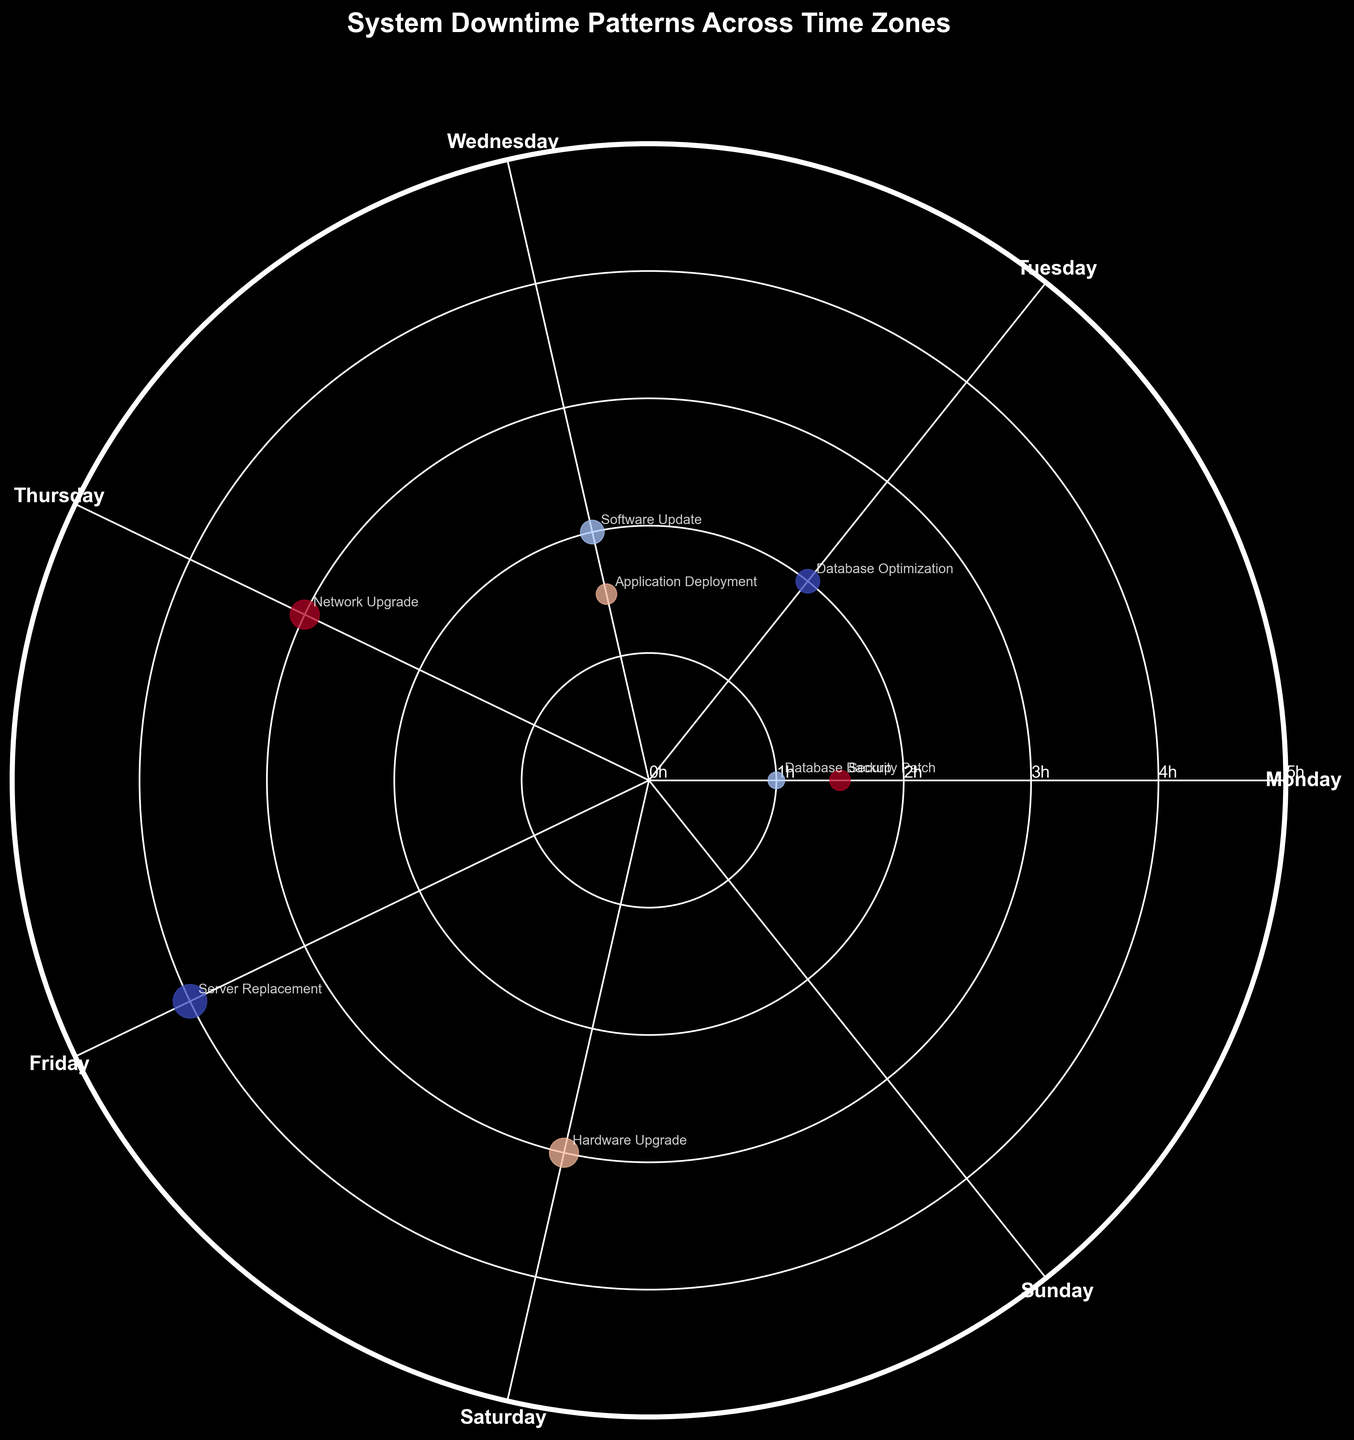What is the maximum system downtime duration displayed in the plot? The maximum downtime can be found by looking at the outermost points along the radial axis. The highest value on the plot is 4 hours.
Answer: 4 hours Which day of the week had the highest total hours of downtime and how many hours was it? To find this, sum up the total downtime hours for each day, then compare the results. The figure shows that Friday had the highest total with 4 hours of downtime.
Answer: Friday, 4 hours Which maintenance activity has the smallest marker size and on what day did it occur? Marker sizes represent hours of downtime. The smallest marker (1 hour), due to its size, is associated with 'Database Backup' on Monday.
Answer: Database Backup, Monday Compare the total downtime hours in PST and EST time zones. Which time zone had more downtime hours and by how many? Sum the downtime hours in EST (1+2=3) and PST (3+1.5=4.5) and then compare. PST had 1.5 more hours of downtime than EST.
Answer: PST, 1.5 hours What patterns are visible in application deployment activities across different time zones? By looking at the positions and labels, application deployment is marked in IST on Wednesday with 1.5 hours of downtime, showing a pattern of occurring mid-week in IST.
Answer: Occurs mid-week in IST with 1.5 hours of downtime How does the radial distance correspond to the variables in the data? The radial distance (distance from the center) in the plot corresponds to the hours of downtime, with larger distances indicating longer downtime durations.
Answer: Hours of downtime On which day did the most varied types of maintenance activities occur? Count the different types of maintenance activities for each day. Monday had varied activities including 'Database Backup' in EST and 'Security Patch' in PST.
Answer: Monday Comparing downtime durations, is there any day where multiple time zones have reported activities? If yes, which day and which time zones? By comparing the days and their associated time zones, Monday had activities reported from EST and PST time zones.
Answer: Monday, EST and PST What is the average downtime duration per maintenance activity? To find this, sum all downtime hours (1+2+3+1.5+2+4+1.5+3=18) and divide by the number of activities (8). This gives an average of 18/8=2.25 hours.
Answer: 2.25 hours Which time zone has a maintenance activity with the maximum downtime, and what is the activity? From the figure, the time zone CET has a 'Server Replacement' activity with 4 hours of downtime, the highest in the dataset.
Answer: CET, Server Replacement 